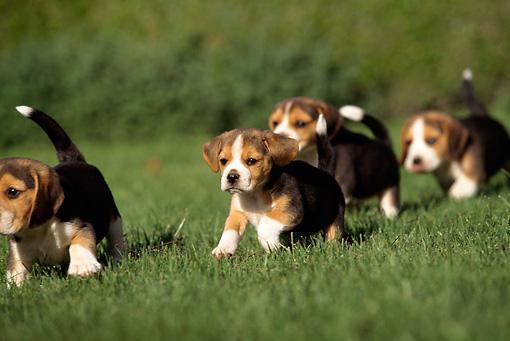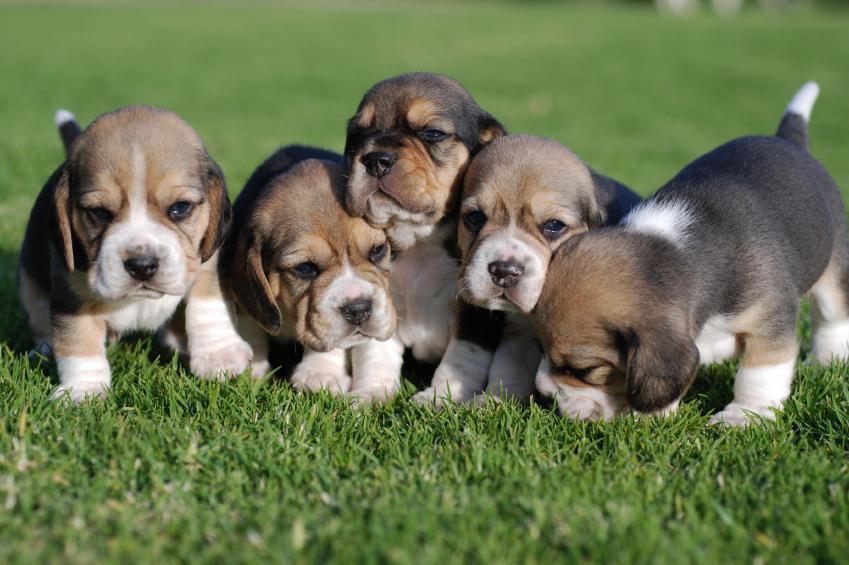The first image is the image on the left, the second image is the image on the right. For the images displayed, is the sentence "Both images in the pair contain only one dog." factually correct? Answer yes or no. No. The first image is the image on the left, the second image is the image on the right. Considering the images on both sides, is "There are no more than two puppies." valid? Answer yes or no. No. 